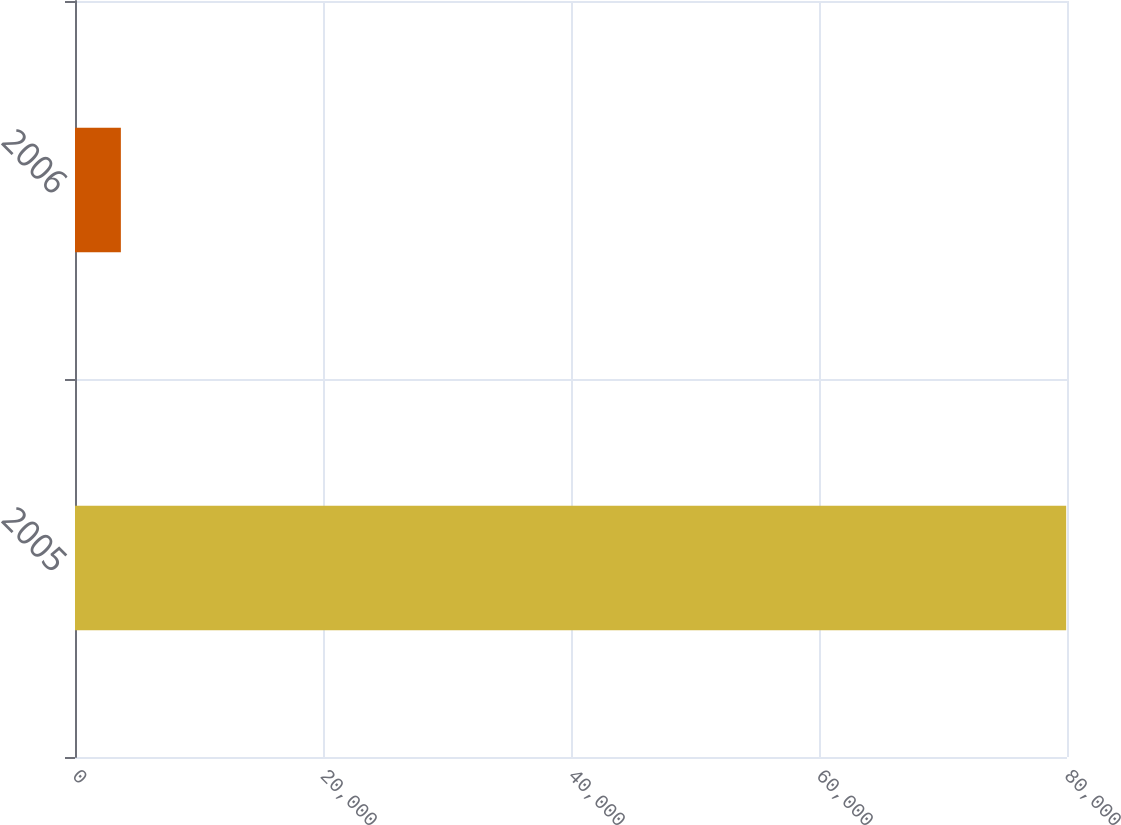Convert chart to OTSL. <chart><loc_0><loc_0><loc_500><loc_500><bar_chart><fcel>2005<fcel>2006<nl><fcel>79932<fcel>3699<nl></chart> 